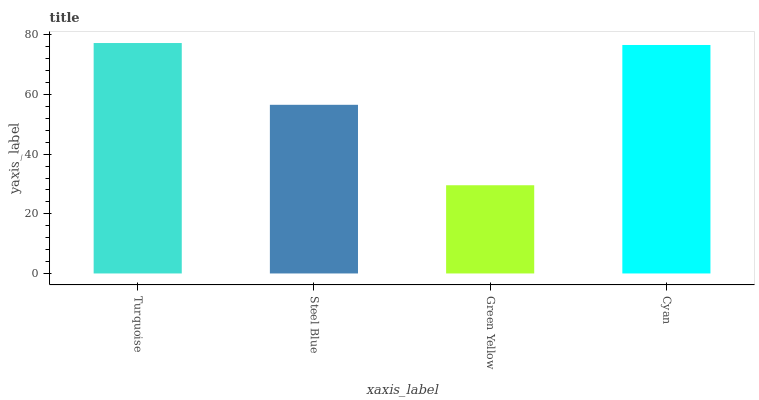Is Green Yellow the minimum?
Answer yes or no. Yes. Is Turquoise the maximum?
Answer yes or no. Yes. Is Steel Blue the minimum?
Answer yes or no. No. Is Steel Blue the maximum?
Answer yes or no. No. Is Turquoise greater than Steel Blue?
Answer yes or no. Yes. Is Steel Blue less than Turquoise?
Answer yes or no. Yes. Is Steel Blue greater than Turquoise?
Answer yes or no. No. Is Turquoise less than Steel Blue?
Answer yes or no. No. Is Cyan the high median?
Answer yes or no. Yes. Is Steel Blue the low median?
Answer yes or no. Yes. Is Green Yellow the high median?
Answer yes or no. No. Is Cyan the low median?
Answer yes or no. No. 